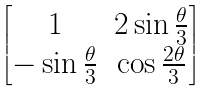<formula> <loc_0><loc_0><loc_500><loc_500>\begin{bmatrix} 1 & 2 \sin \frac { \theta } 3 \\ - \sin \frac { \theta } 3 & \cos \frac { 2 \theta } 3 \end{bmatrix}</formula> 